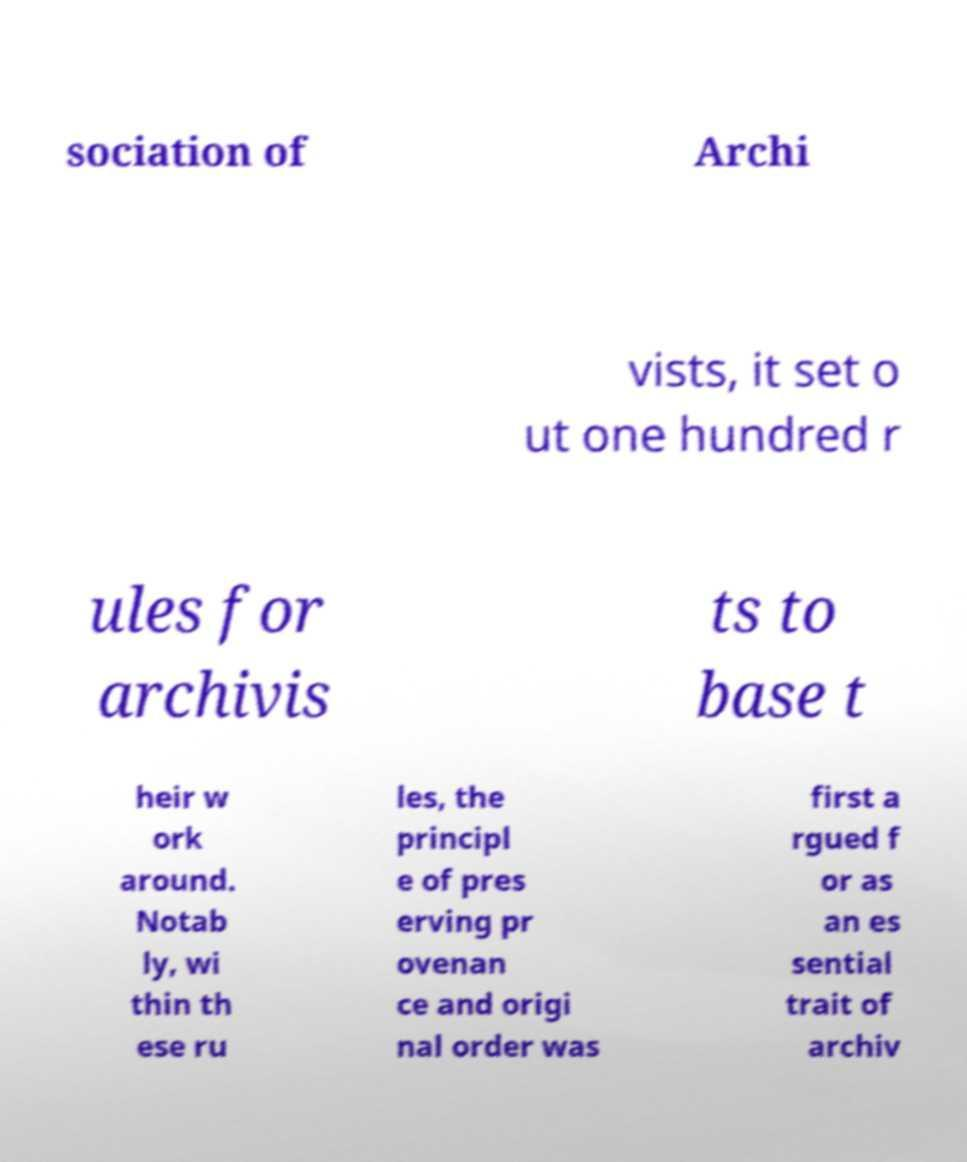Can you read and provide the text displayed in the image?This photo seems to have some interesting text. Can you extract and type it out for me? sociation of Archi vists, it set o ut one hundred r ules for archivis ts to base t heir w ork around. Notab ly, wi thin th ese ru les, the principl e of pres erving pr ovenan ce and origi nal order was first a rgued f or as an es sential trait of archiv 